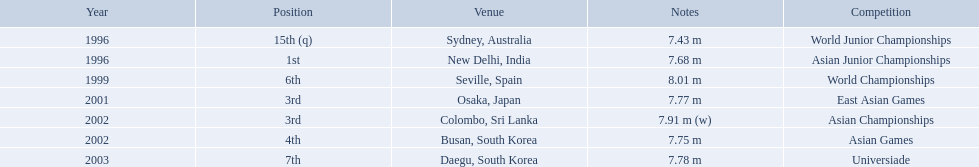What are all of the competitions? World Junior Championships, Asian Junior Championships, World Championships, East Asian Games, Asian Championships, Asian Games, Universiade. What was his positions in these competitions? 15th (q), 1st, 6th, 3rd, 3rd, 4th, 7th. And during which competition did he reach 1st place? Asian Junior Championships. 